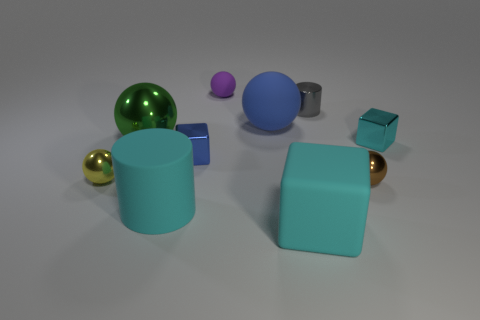Subtract 0 gray spheres. How many objects are left? 10 Subtract all cylinders. How many objects are left? 8 Subtract 2 blocks. How many blocks are left? 1 Subtract all brown cubes. Subtract all red cylinders. How many cubes are left? 3 Subtract all green balls. How many yellow cylinders are left? 0 Subtract all tiny cyan rubber cylinders. Subtract all large blue rubber objects. How many objects are left? 9 Add 4 large blocks. How many large blocks are left? 5 Add 9 tiny purple balls. How many tiny purple balls exist? 10 Subtract all gray cylinders. How many cylinders are left? 1 Subtract all large green metal spheres. How many spheres are left? 4 